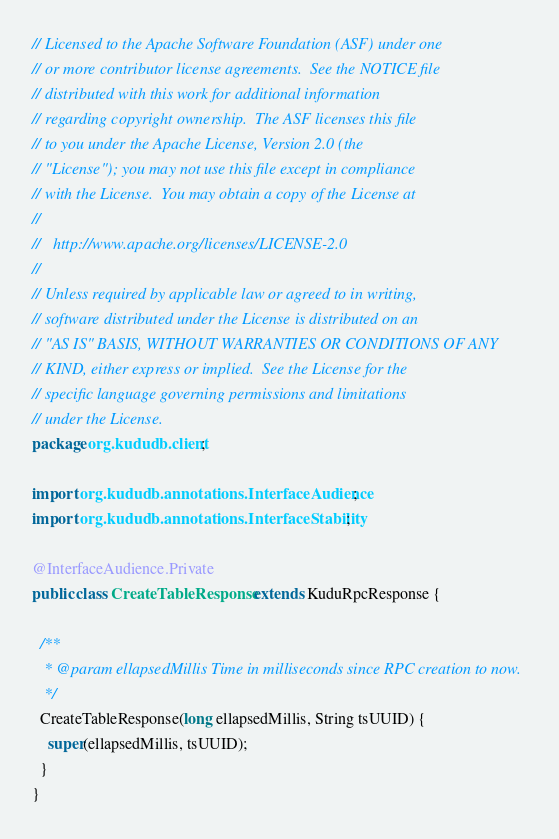Convert code to text. <code><loc_0><loc_0><loc_500><loc_500><_Java_>// Licensed to the Apache Software Foundation (ASF) under one
// or more contributor license agreements.  See the NOTICE file
// distributed with this work for additional information
// regarding copyright ownership.  The ASF licenses this file
// to you under the Apache License, Version 2.0 (the
// "License"); you may not use this file except in compliance
// with the License.  You may obtain a copy of the License at
//
//   http://www.apache.org/licenses/LICENSE-2.0
//
// Unless required by applicable law or agreed to in writing,
// software distributed under the License is distributed on an
// "AS IS" BASIS, WITHOUT WARRANTIES OR CONDITIONS OF ANY
// KIND, either express or implied.  See the License for the
// specific language governing permissions and limitations
// under the License.
package org.kududb.client;

import org.kududb.annotations.InterfaceAudience;
import org.kududb.annotations.InterfaceStability;

@InterfaceAudience.Private
public class CreateTableResponse extends KuduRpcResponse {

  /**
   * @param ellapsedMillis Time in milliseconds since RPC creation to now.
   */
  CreateTableResponse(long ellapsedMillis, String tsUUID) {
    super(ellapsedMillis, tsUUID);
  }
}
</code> 